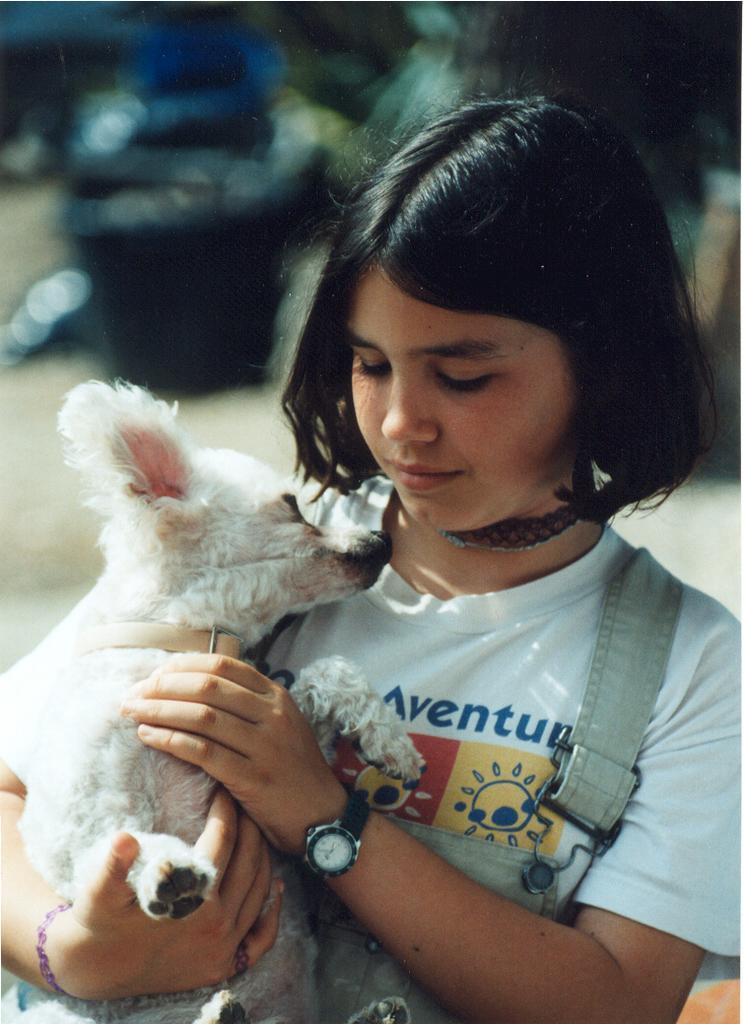How would you summarize this image in a sentence or two? This picture is mainly highlighted with a girl holding a puppy in her hands. She has a short hair in black colour. Background is very blurry. 